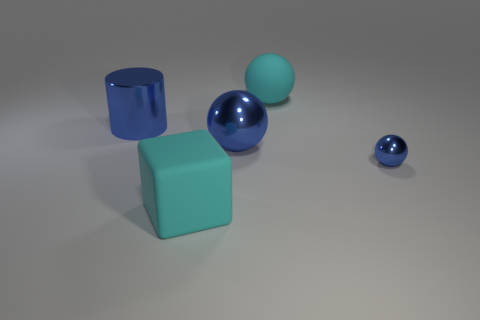Add 1 big metallic balls. How many objects exist? 6 Subtract all blue balls. How many balls are left? 1 Subtract all green blocks. How many blue balls are left? 2 Subtract all yellow balls. Subtract all yellow cylinders. How many balls are left? 3 Subtract all cyan matte blocks. Subtract all cylinders. How many objects are left? 3 Add 1 matte blocks. How many matte blocks are left? 2 Add 1 big cyan objects. How many big cyan objects exist? 3 Subtract all cyan spheres. How many spheres are left? 2 Subtract 0 green cubes. How many objects are left? 5 Subtract all cubes. How many objects are left? 4 